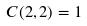Convert formula to latex. <formula><loc_0><loc_0><loc_500><loc_500>C ( 2 , 2 ) = 1</formula> 